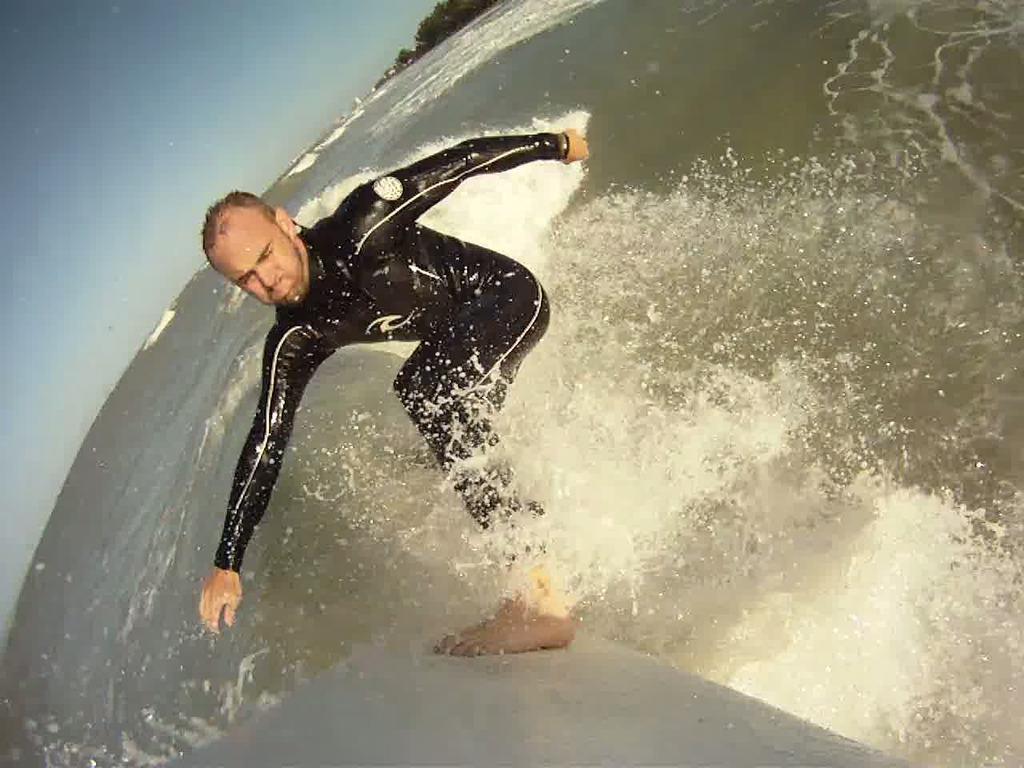In one or two sentences, can you explain what this image depicts? We can see a man surfing on the surface of the water. We can also see the trees and also the sky. 